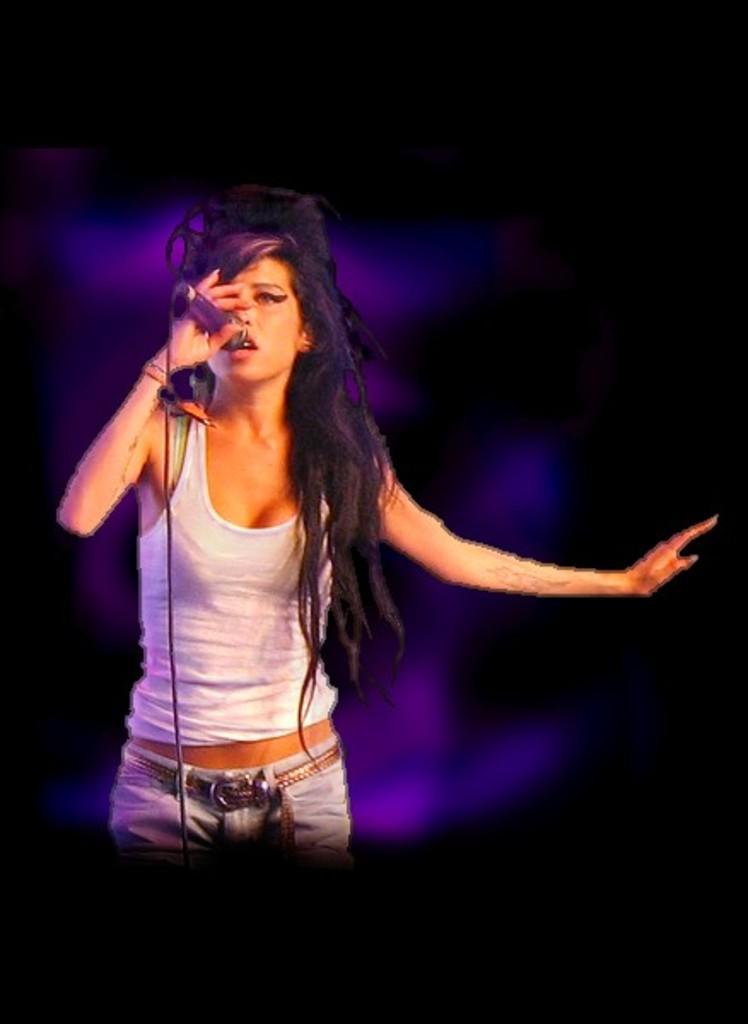Please provide a concise description of this image. On the left side, there is a woman in white color t-shirt, holding a mic, singing and standing. And the background is dark in color. 